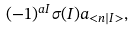Convert formula to latex. <formula><loc_0><loc_0><loc_500><loc_500>( - 1 ) ^ { a I } \sigma ( I ) a _ { < n | I > } ,</formula> 